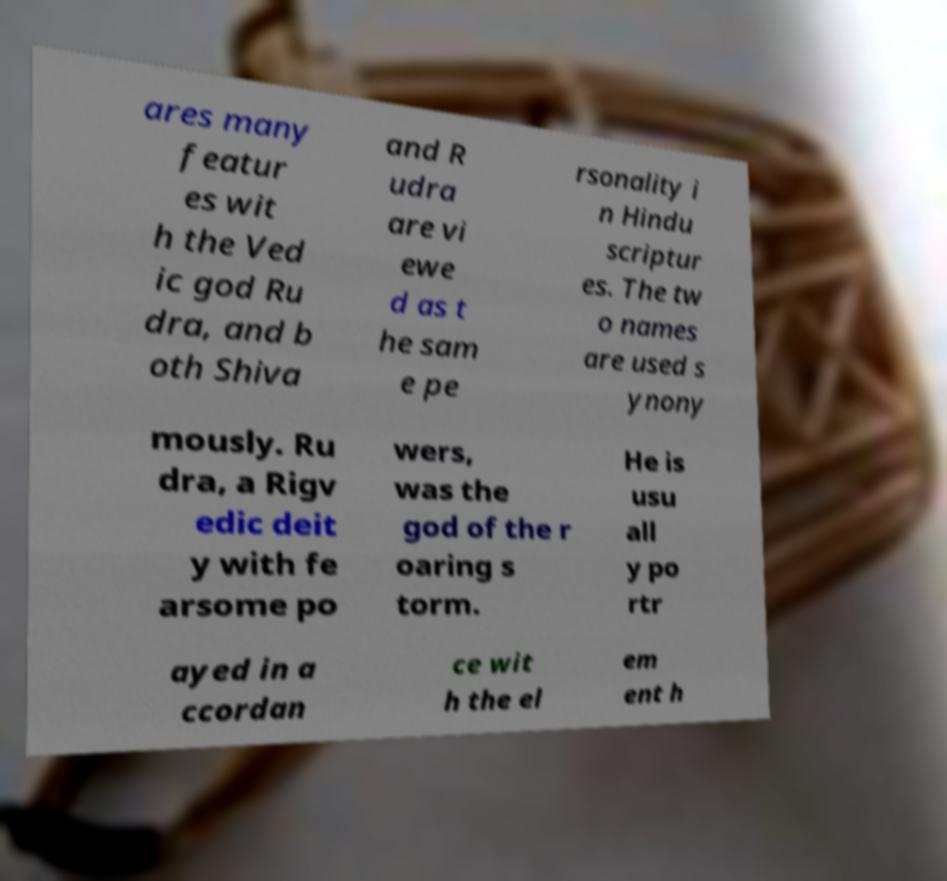Can you read and provide the text displayed in the image?This photo seems to have some interesting text. Can you extract and type it out for me? ares many featur es wit h the Ved ic god Ru dra, and b oth Shiva and R udra are vi ewe d as t he sam e pe rsonality i n Hindu scriptur es. The tw o names are used s ynony mously. Ru dra, a Rigv edic deit y with fe arsome po wers, was the god of the r oaring s torm. He is usu all y po rtr ayed in a ccordan ce wit h the el em ent h 